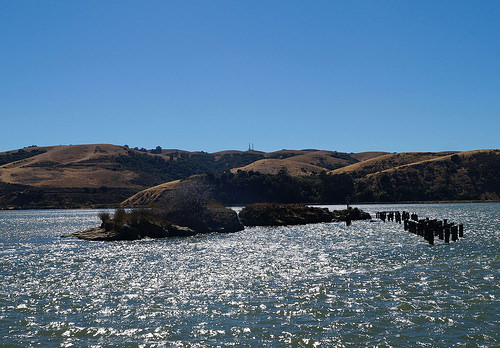<image>
Is the hill in front of the lake? No. The hill is not in front of the lake. The spatial positioning shows a different relationship between these objects. 